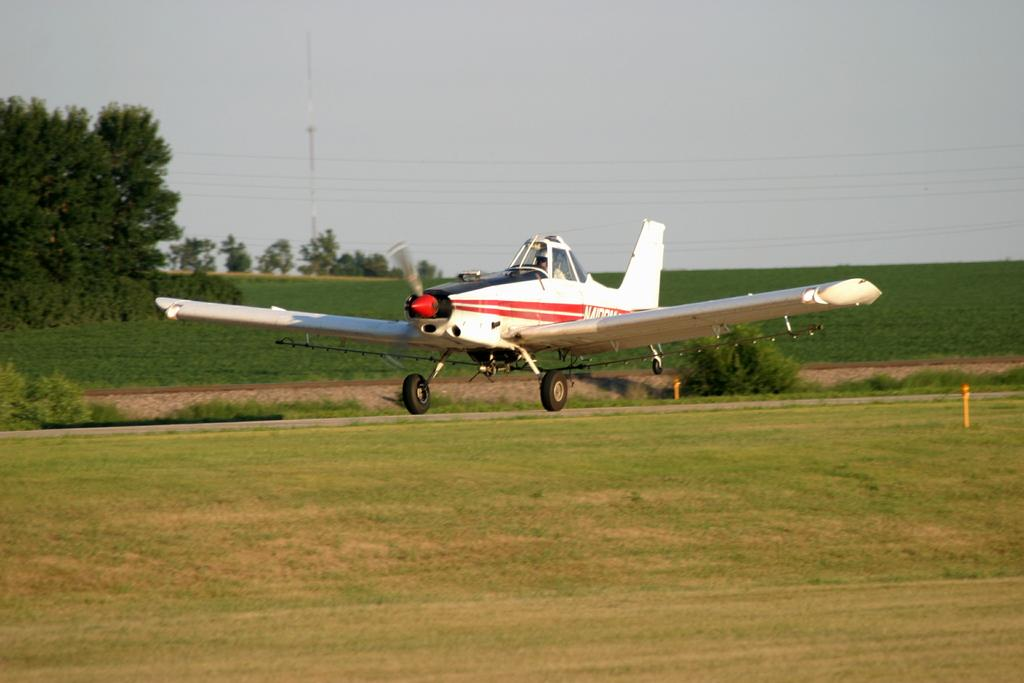What is the main subject of the image? The main subject of the image is a jet plane. What is the color of the jet plane? The jet plane is white in color. What type of vegetation is at the bottom of the image? There is green grass at the bottom of the image. What can be seen in the background of the image? There are trees in the background of the image. What is visible at the top of the image? The sky is visible at the top of the image. What type of juice is being served on the jet plane in the image? There is no juice or any indication of a service on the jet plane in the image; it is simply a white jet plane. 